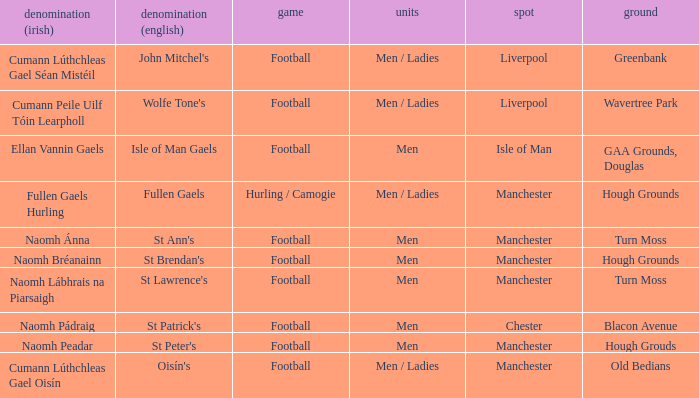What is the English Name of the Location in Chester? St Patrick's. 